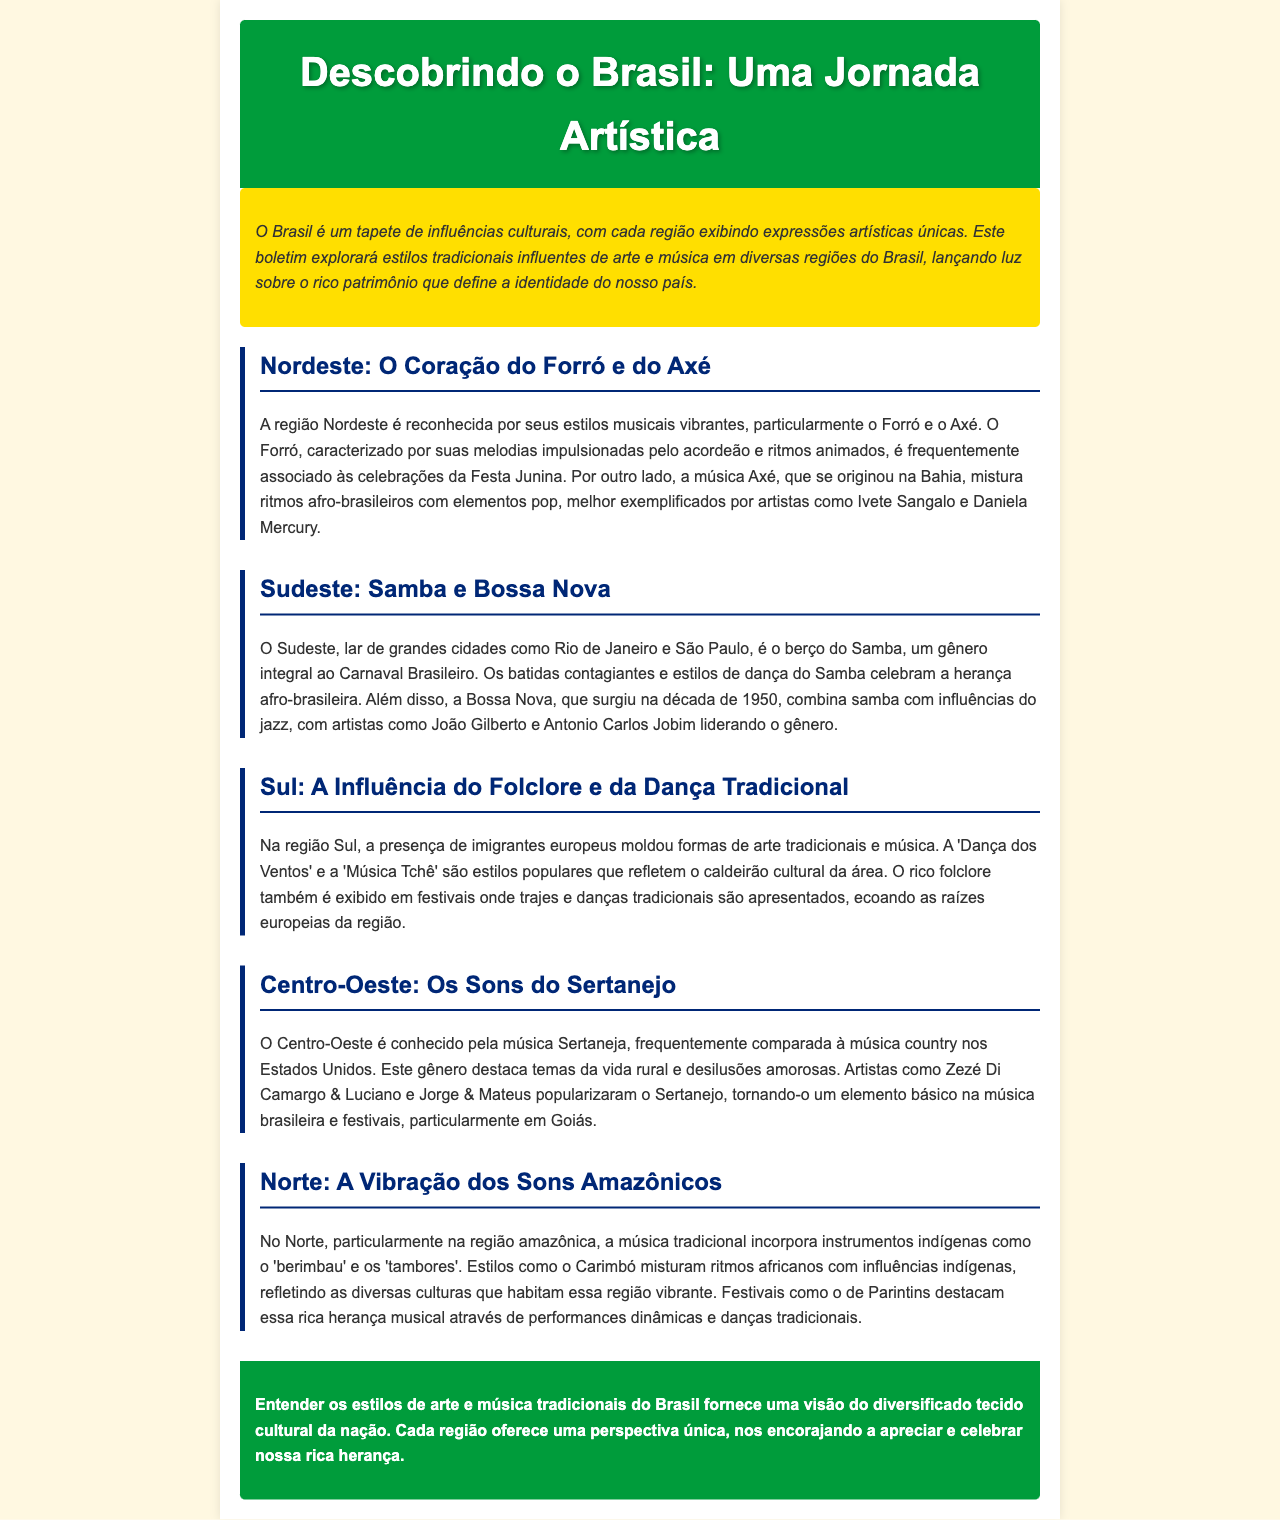Qual é a música tradicional associada à Festa Junina? O documento menciona que o Forró é frequentemente associado às celebrações da Festa Junina.
Answer: Forró Quem são dois artistas exemplares do gênero Axé? Artistas como Ivete Sangalo e Daniela Mercury são mencionados como exemplares do gênero Axé.
Answer: Ivete Sangalo e Daniela Mercury Qual região do Brasil é conhecida pelo gênero musical Sertanejo? O texto indica que o Centro-Oeste é conhecido pela música Sertaneja.
Answer: Centro-Oeste Quais ritmos são misturados no Carimbó? O Carimbó mistura ritmos africanos com influências indígenas, de acordo com o documento.
Answer: Ritmos africanos e influências indígenas Que dança tradicional é popular na região Sul do Brasil? O documento menciona a 'Dança dos Ventos' como um estilo popular na região Sul.
Answer: Dança dos Ventos Em que década surgiu a Bossa Nova? O documento afirma que a Bossa Nova surgiu na década de 1950.
Answer: Década de 1950 Quais são os principais instrumentos usados na música amazônica? O texto indica que instrumentos indígenas como o 'berimbau' e os 'tambores' são usados na música tradicional do Norte.
Answer: Berimbau e tambores Qual festival destaca a herança musical da região amazônica? O festival de Parintins é mencionado como um destaque da rica herança musical dessa região.
Answer: Festival de Parintins O que o documento destaca sobre a música e arte brasileiras? O texto conclui que entender os estilos tradicionais oferece uma visão do diversificado tecido cultural do Brasil.
Answer: Tecido cultural diversificado 